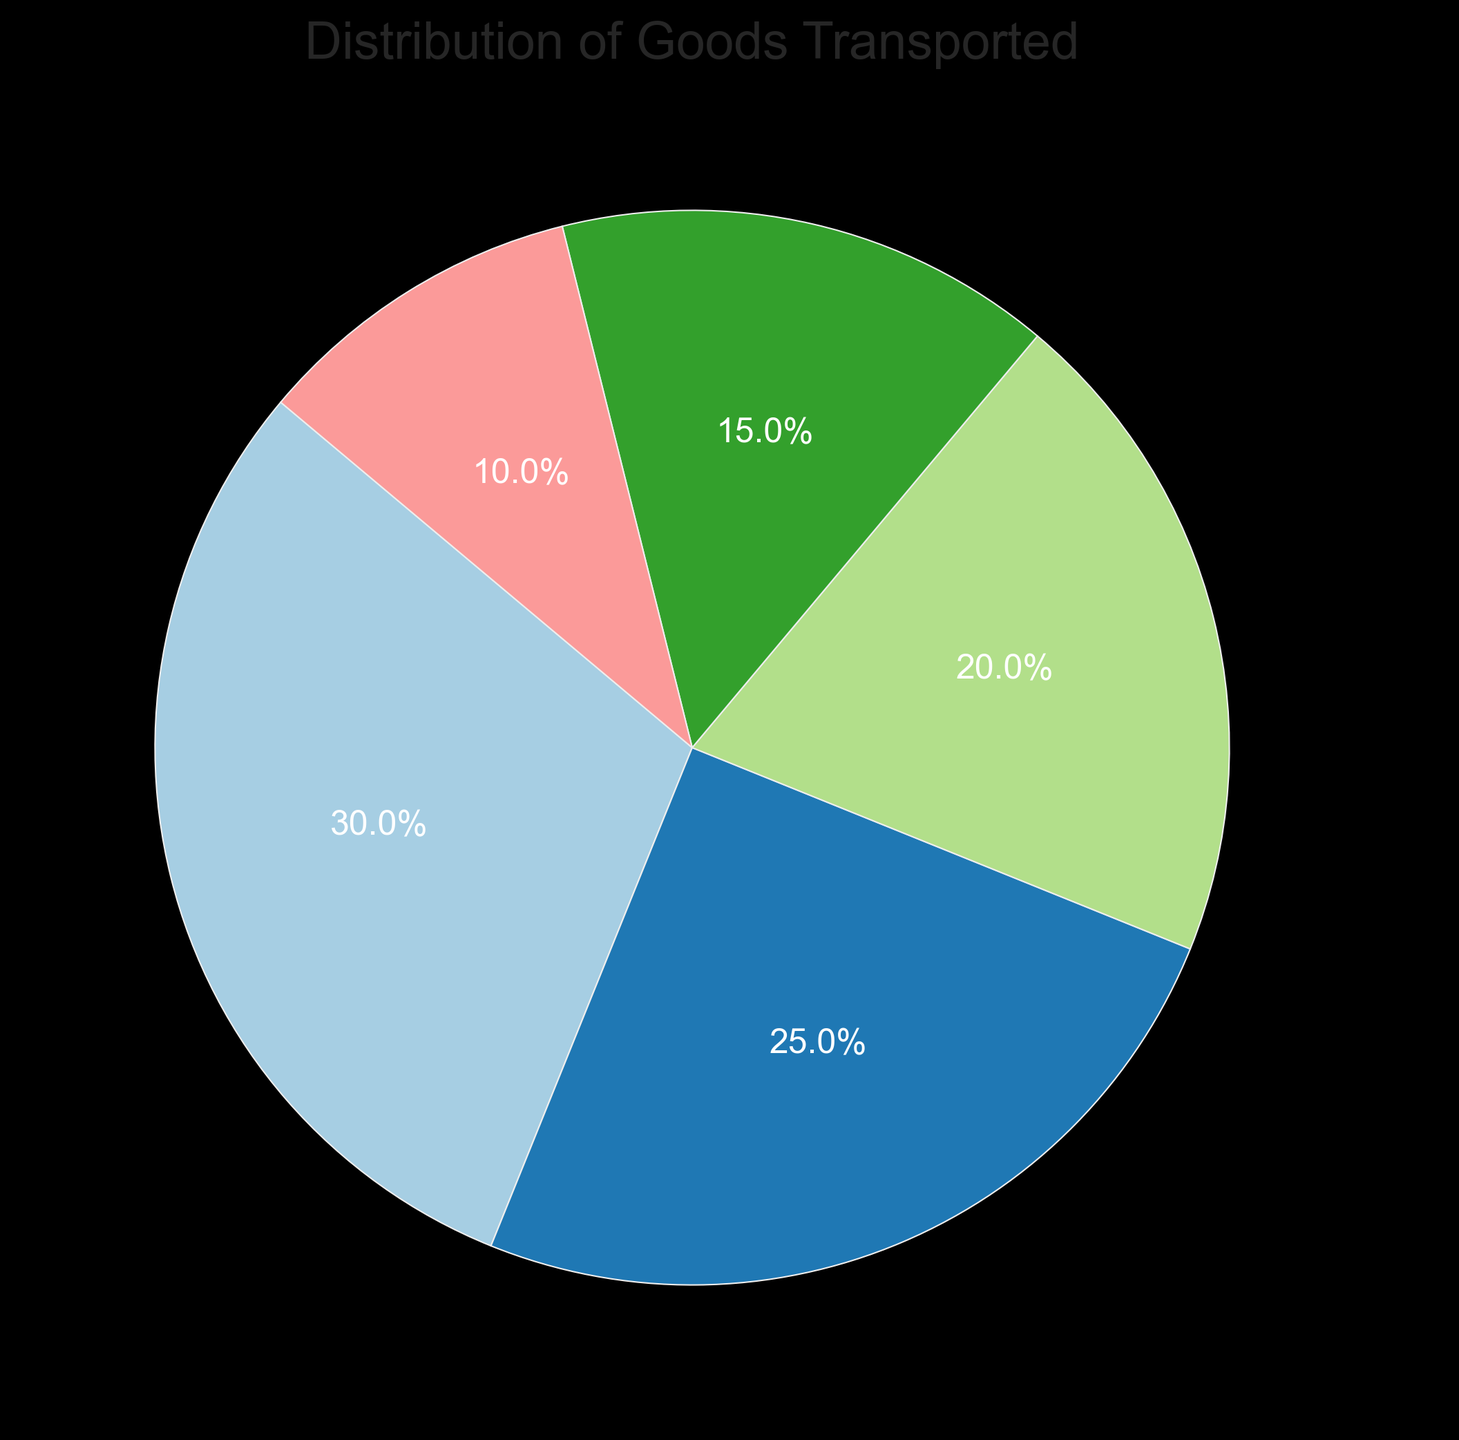What percentage of goods transported is categorized as 'Food'? The pie chart indicates the proportion of each category. The segment labeled 'Food' shows 30%, which represents 30% of the goods transported.
Answer: 30% Which category of goods has the smallest transported percentage, and what is that percentage? By looking at the pie chart, the 'Other' category has the smallest segment, which is labeled as 10%.
Answer: Other, 10% What is the combined percentage of goods transported for Electronics and Automotive? To find the combined percentage, sum the percentages for Electronics (25%) and Automotive (20%). 25% + 20% = 45%.
Answer: 45% Which category has a higher transported percentage, Food or Clothing, and by how much? By observing the pie chart, Food is 30% and Clothing is 15%. The difference is 30% - 15% = 15%.
Answer: Food, 15% How many more percentage points of goods does the Food category represent compared to the Other category? Food accounts for 30% and Other accounts for 10%. The difference is 30% - 10% = 20 percentage points.
Answer: 20 If you were to combine Clothing and Other items into a single category, what percentage of goods would this new category represent? Sum the percentages of Clothing (15%) and Other (10%) to get 25%.
Answer: 25% Which two categories together account for less than half of the goods transported, and what is their combined percentage? Automotive (20%) and Clothing (15%). When added together, 20% + 15% = 35%, which is less than 50%.
Answer: Automotive and Clothing, 35% What is the visual attribute of the wedge representing Electronics in terms of its color? The wedge for Electronics is visually distinct with one of the colors from the 'Paired' color map used in the pie chart, but you need to identify it specifically on the chart to answer what exact color it has.
Answer: (Identify color visually on chart) Which category's proportion of goods transported is closest to a quarter of the total, and what is the exact percentage? By inspecting the chart, Electronics has 25%, which is exactly a quarter (25%) of the total.
Answer: Electronics, 25% 